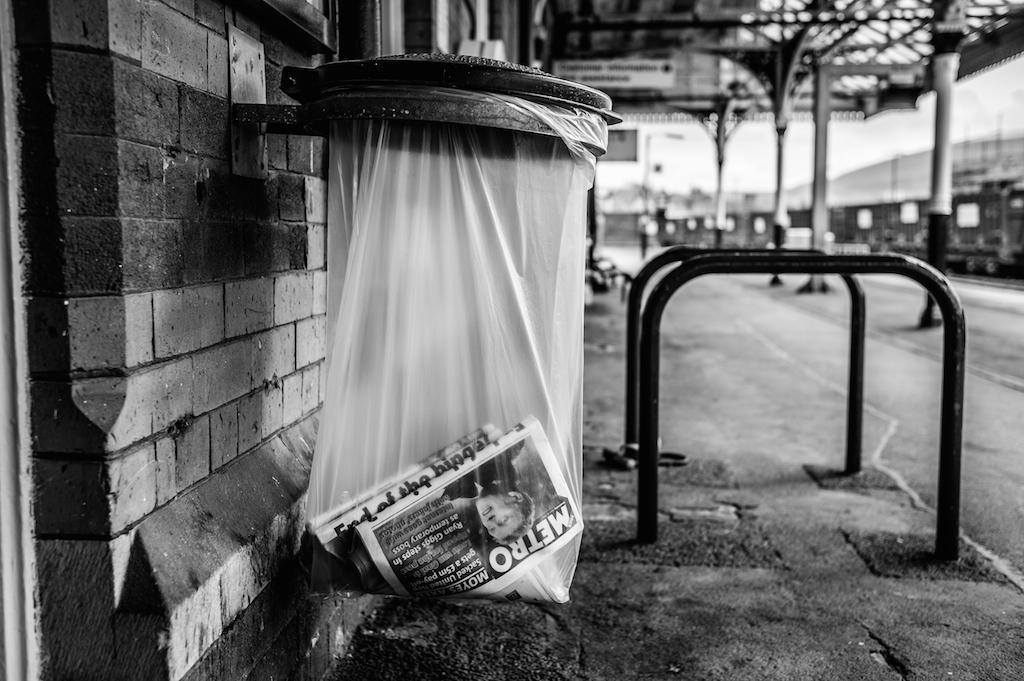<image>
Describe the image concisely. A newspaper with METRO written on is sits inside of a clear trash bag 